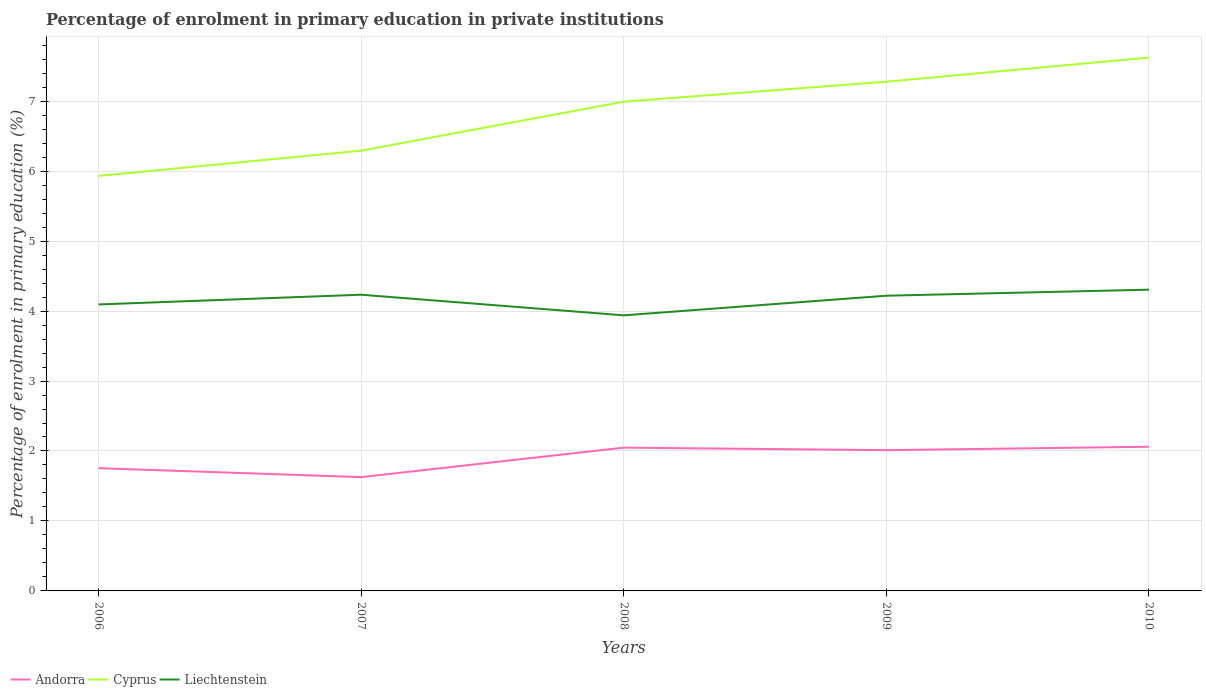Does the line corresponding to Liechtenstein intersect with the line corresponding to Cyprus?
Give a very brief answer. No. Is the number of lines equal to the number of legend labels?
Your answer should be very brief. Yes. Across all years, what is the maximum percentage of enrolment in primary education in Cyprus?
Provide a succinct answer. 5.93. What is the total percentage of enrolment in primary education in Andorra in the graph?
Provide a succinct answer. -0.42. What is the difference between the highest and the second highest percentage of enrolment in primary education in Andorra?
Keep it short and to the point. 0.43. What is the difference between the highest and the lowest percentage of enrolment in primary education in Andorra?
Provide a succinct answer. 3. How many years are there in the graph?
Offer a terse response. 5. Are the values on the major ticks of Y-axis written in scientific E-notation?
Keep it short and to the point. No. Does the graph contain any zero values?
Your answer should be very brief. No. Does the graph contain grids?
Your answer should be compact. Yes. Where does the legend appear in the graph?
Offer a terse response. Bottom left. How many legend labels are there?
Your answer should be compact. 3. What is the title of the graph?
Keep it short and to the point. Percentage of enrolment in primary education in private institutions. Does "Egypt, Arab Rep." appear as one of the legend labels in the graph?
Provide a short and direct response. No. What is the label or title of the Y-axis?
Your response must be concise. Percentage of enrolment in primary education (%). What is the Percentage of enrolment in primary education (%) in Andorra in 2006?
Provide a succinct answer. 1.75. What is the Percentage of enrolment in primary education (%) of Cyprus in 2006?
Offer a very short reply. 5.93. What is the Percentage of enrolment in primary education (%) in Liechtenstein in 2006?
Ensure brevity in your answer.  4.09. What is the Percentage of enrolment in primary education (%) of Andorra in 2007?
Offer a terse response. 1.63. What is the Percentage of enrolment in primary education (%) of Cyprus in 2007?
Your answer should be very brief. 6.29. What is the Percentage of enrolment in primary education (%) of Liechtenstein in 2007?
Offer a terse response. 4.23. What is the Percentage of enrolment in primary education (%) in Andorra in 2008?
Your answer should be very brief. 2.05. What is the Percentage of enrolment in primary education (%) of Cyprus in 2008?
Provide a short and direct response. 6.99. What is the Percentage of enrolment in primary education (%) of Liechtenstein in 2008?
Keep it short and to the point. 3.94. What is the Percentage of enrolment in primary education (%) in Andorra in 2009?
Make the answer very short. 2.01. What is the Percentage of enrolment in primary education (%) in Cyprus in 2009?
Provide a short and direct response. 7.28. What is the Percentage of enrolment in primary education (%) of Liechtenstein in 2009?
Your answer should be compact. 4.22. What is the Percentage of enrolment in primary education (%) of Andorra in 2010?
Keep it short and to the point. 2.06. What is the Percentage of enrolment in primary education (%) in Cyprus in 2010?
Your answer should be very brief. 7.62. What is the Percentage of enrolment in primary education (%) in Liechtenstein in 2010?
Provide a succinct answer. 4.31. Across all years, what is the maximum Percentage of enrolment in primary education (%) of Andorra?
Offer a very short reply. 2.06. Across all years, what is the maximum Percentage of enrolment in primary education (%) in Cyprus?
Your answer should be compact. 7.62. Across all years, what is the maximum Percentage of enrolment in primary education (%) in Liechtenstein?
Make the answer very short. 4.31. Across all years, what is the minimum Percentage of enrolment in primary education (%) in Andorra?
Provide a succinct answer. 1.63. Across all years, what is the minimum Percentage of enrolment in primary education (%) of Cyprus?
Your answer should be very brief. 5.93. Across all years, what is the minimum Percentage of enrolment in primary education (%) in Liechtenstein?
Ensure brevity in your answer.  3.94. What is the total Percentage of enrolment in primary education (%) of Andorra in the graph?
Offer a terse response. 9.5. What is the total Percentage of enrolment in primary education (%) of Cyprus in the graph?
Your answer should be very brief. 34.12. What is the total Percentage of enrolment in primary education (%) in Liechtenstein in the graph?
Provide a short and direct response. 20.79. What is the difference between the Percentage of enrolment in primary education (%) in Andorra in 2006 and that in 2007?
Make the answer very short. 0.13. What is the difference between the Percentage of enrolment in primary education (%) of Cyprus in 2006 and that in 2007?
Your response must be concise. -0.36. What is the difference between the Percentage of enrolment in primary education (%) in Liechtenstein in 2006 and that in 2007?
Provide a succinct answer. -0.14. What is the difference between the Percentage of enrolment in primary education (%) in Andorra in 2006 and that in 2008?
Keep it short and to the point. -0.29. What is the difference between the Percentage of enrolment in primary education (%) in Cyprus in 2006 and that in 2008?
Make the answer very short. -1.06. What is the difference between the Percentage of enrolment in primary education (%) of Liechtenstein in 2006 and that in 2008?
Offer a very short reply. 0.16. What is the difference between the Percentage of enrolment in primary education (%) in Andorra in 2006 and that in 2009?
Offer a terse response. -0.26. What is the difference between the Percentage of enrolment in primary education (%) in Cyprus in 2006 and that in 2009?
Make the answer very short. -1.35. What is the difference between the Percentage of enrolment in primary education (%) of Liechtenstein in 2006 and that in 2009?
Offer a terse response. -0.13. What is the difference between the Percentage of enrolment in primary education (%) of Andorra in 2006 and that in 2010?
Offer a very short reply. -0.31. What is the difference between the Percentage of enrolment in primary education (%) of Cyprus in 2006 and that in 2010?
Your response must be concise. -1.69. What is the difference between the Percentage of enrolment in primary education (%) of Liechtenstein in 2006 and that in 2010?
Your answer should be compact. -0.21. What is the difference between the Percentage of enrolment in primary education (%) in Andorra in 2007 and that in 2008?
Offer a very short reply. -0.42. What is the difference between the Percentage of enrolment in primary education (%) in Cyprus in 2007 and that in 2008?
Your response must be concise. -0.7. What is the difference between the Percentage of enrolment in primary education (%) of Liechtenstein in 2007 and that in 2008?
Offer a terse response. 0.29. What is the difference between the Percentage of enrolment in primary education (%) of Andorra in 2007 and that in 2009?
Your response must be concise. -0.39. What is the difference between the Percentage of enrolment in primary education (%) in Cyprus in 2007 and that in 2009?
Keep it short and to the point. -0.99. What is the difference between the Percentage of enrolment in primary education (%) in Liechtenstein in 2007 and that in 2009?
Your response must be concise. 0.01. What is the difference between the Percentage of enrolment in primary education (%) in Andorra in 2007 and that in 2010?
Provide a succinct answer. -0.43. What is the difference between the Percentage of enrolment in primary education (%) in Cyprus in 2007 and that in 2010?
Provide a succinct answer. -1.33. What is the difference between the Percentage of enrolment in primary education (%) in Liechtenstein in 2007 and that in 2010?
Make the answer very short. -0.07. What is the difference between the Percentage of enrolment in primary education (%) in Andorra in 2008 and that in 2009?
Give a very brief answer. 0.04. What is the difference between the Percentage of enrolment in primary education (%) of Cyprus in 2008 and that in 2009?
Offer a very short reply. -0.29. What is the difference between the Percentage of enrolment in primary education (%) in Liechtenstein in 2008 and that in 2009?
Your answer should be compact. -0.28. What is the difference between the Percentage of enrolment in primary education (%) in Andorra in 2008 and that in 2010?
Provide a short and direct response. -0.01. What is the difference between the Percentage of enrolment in primary education (%) in Cyprus in 2008 and that in 2010?
Offer a very short reply. -0.63. What is the difference between the Percentage of enrolment in primary education (%) in Liechtenstein in 2008 and that in 2010?
Offer a very short reply. -0.37. What is the difference between the Percentage of enrolment in primary education (%) in Andorra in 2009 and that in 2010?
Provide a short and direct response. -0.05. What is the difference between the Percentage of enrolment in primary education (%) of Cyprus in 2009 and that in 2010?
Your answer should be very brief. -0.34. What is the difference between the Percentage of enrolment in primary education (%) of Liechtenstein in 2009 and that in 2010?
Give a very brief answer. -0.09. What is the difference between the Percentage of enrolment in primary education (%) of Andorra in 2006 and the Percentage of enrolment in primary education (%) of Cyprus in 2007?
Give a very brief answer. -4.54. What is the difference between the Percentage of enrolment in primary education (%) in Andorra in 2006 and the Percentage of enrolment in primary education (%) in Liechtenstein in 2007?
Keep it short and to the point. -2.48. What is the difference between the Percentage of enrolment in primary education (%) of Cyprus in 2006 and the Percentage of enrolment in primary education (%) of Liechtenstein in 2007?
Your response must be concise. 1.7. What is the difference between the Percentage of enrolment in primary education (%) in Andorra in 2006 and the Percentage of enrolment in primary education (%) in Cyprus in 2008?
Give a very brief answer. -5.24. What is the difference between the Percentage of enrolment in primary education (%) in Andorra in 2006 and the Percentage of enrolment in primary education (%) in Liechtenstein in 2008?
Give a very brief answer. -2.18. What is the difference between the Percentage of enrolment in primary education (%) in Cyprus in 2006 and the Percentage of enrolment in primary education (%) in Liechtenstein in 2008?
Your response must be concise. 1.99. What is the difference between the Percentage of enrolment in primary education (%) of Andorra in 2006 and the Percentage of enrolment in primary education (%) of Cyprus in 2009?
Make the answer very short. -5.52. What is the difference between the Percentage of enrolment in primary education (%) in Andorra in 2006 and the Percentage of enrolment in primary education (%) in Liechtenstein in 2009?
Give a very brief answer. -2.46. What is the difference between the Percentage of enrolment in primary education (%) of Cyprus in 2006 and the Percentage of enrolment in primary education (%) of Liechtenstein in 2009?
Your response must be concise. 1.71. What is the difference between the Percentage of enrolment in primary education (%) of Andorra in 2006 and the Percentage of enrolment in primary education (%) of Cyprus in 2010?
Ensure brevity in your answer.  -5.87. What is the difference between the Percentage of enrolment in primary education (%) of Andorra in 2006 and the Percentage of enrolment in primary education (%) of Liechtenstein in 2010?
Ensure brevity in your answer.  -2.55. What is the difference between the Percentage of enrolment in primary education (%) of Cyprus in 2006 and the Percentage of enrolment in primary education (%) of Liechtenstein in 2010?
Provide a short and direct response. 1.63. What is the difference between the Percentage of enrolment in primary education (%) of Andorra in 2007 and the Percentage of enrolment in primary education (%) of Cyprus in 2008?
Keep it short and to the point. -5.37. What is the difference between the Percentage of enrolment in primary education (%) of Andorra in 2007 and the Percentage of enrolment in primary education (%) of Liechtenstein in 2008?
Keep it short and to the point. -2.31. What is the difference between the Percentage of enrolment in primary education (%) in Cyprus in 2007 and the Percentage of enrolment in primary education (%) in Liechtenstein in 2008?
Provide a short and direct response. 2.35. What is the difference between the Percentage of enrolment in primary education (%) of Andorra in 2007 and the Percentage of enrolment in primary education (%) of Cyprus in 2009?
Offer a very short reply. -5.65. What is the difference between the Percentage of enrolment in primary education (%) of Andorra in 2007 and the Percentage of enrolment in primary education (%) of Liechtenstein in 2009?
Your answer should be compact. -2.59. What is the difference between the Percentage of enrolment in primary education (%) of Cyprus in 2007 and the Percentage of enrolment in primary education (%) of Liechtenstein in 2009?
Offer a terse response. 2.07. What is the difference between the Percentage of enrolment in primary education (%) in Andorra in 2007 and the Percentage of enrolment in primary education (%) in Cyprus in 2010?
Your answer should be very brief. -6. What is the difference between the Percentage of enrolment in primary education (%) in Andorra in 2007 and the Percentage of enrolment in primary education (%) in Liechtenstein in 2010?
Provide a succinct answer. -2.68. What is the difference between the Percentage of enrolment in primary education (%) of Cyprus in 2007 and the Percentage of enrolment in primary education (%) of Liechtenstein in 2010?
Your answer should be compact. 1.99. What is the difference between the Percentage of enrolment in primary education (%) of Andorra in 2008 and the Percentage of enrolment in primary education (%) of Cyprus in 2009?
Make the answer very short. -5.23. What is the difference between the Percentage of enrolment in primary education (%) of Andorra in 2008 and the Percentage of enrolment in primary education (%) of Liechtenstein in 2009?
Keep it short and to the point. -2.17. What is the difference between the Percentage of enrolment in primary education (%) of Cyprus in 2008 and the Percentage of enrolment in primary education (%) of Liechtenstein in 2009?
Provide a succinct answer. 2.77. What is the difference between the Percentage of enrolment in primary education (%) of Andorra in 2008 and the Percentage of enrolment in primary education (%) of Cyprus in 2010?
Give a very brief answer. -5.58. What is the difference between the Percentage of enrolment in primary education (%) in Andorra in 2008 and the Percentage of enrolment in primary education (%) in Liechtenstein in 2010?
Your response must be concise. -2.26. What is the difference between the Percentage of enrolment in primary education (%) of Cyprus in 2008 and the Percentage of enrolment in primary education (%) of Liechtenstein in 2010?
Provide a short and direct response. 2.69. What is the difference between the Percentage of enrolment in primary education (%) of Andorra in 2009 and the Percentage of enrolment in primary education (%) of Cyprus in 2010?
Give a very brief answer. -5.61. What is the difference between the Percentage of enrolment in primary education (%) of Andorra in 2009 and the Percentage of enrolment in primary education (%) of Liechtenstein in 2010?
Provide a short and direct response. -2.29. What is the difference between the Percentage of enrolment in primary education (%) in Cyprus in 2009 and the Percentage of enrolment in primary education (%) in Liechtenstein in 2010?
Offer a very short reply. 2.97. What is the average Percentage of enrolment in primary education (%) of Andorra per year?
Offer a terse response. 1.9. What is the average Percentage of enrolment in primary education (%) in Cyprus per year?
Give a very brief answer. 6.82. What is the average Percentage of enrolment in primary education (%) of Liechtenstein per year?
Keep it short and to the point. 4.16. In the year 2006, what is the difference between the Percentage of enrolment in primary education (%) of Andorra and Percentage of enrolment in primary education (%) of Cyprus?
Make the answer very short. -4.18. In the year 2006, what is the difference between the Percentage of enrolment in primary education (%) in Andorra and Percentage of enrolment in primary education (%) in Liechtenstein?
Give a very brief answer. -2.34. In the year 2006, what is the difference between the Percentage of enrolment in primary education (%) of Cyprus and Percentage of enrolment in primary education (%) of Liechtenstein?
Your answer should be very brief. 1.84. In the year 2007, what is the difference between the Percentage of enrolment in primary education (%) of Andorra and Percentage of enrolment in primary education (%) of Cyprus?
Offer a terse response. -4.67. In the year 2007, what is the difference between the Percentage of enrolment in primary education (%) in Andorra and Percentage of enrolment in primary education (%) in Liechtenstein?
Provide a succinct answer. -2.61. In the year 2007, what is the difference between the Percentage of enrolment in primary education (%) of Cyprus and Percentage of enrolment in primary education (%) of Liechtenstein?
Your answer should be compact. 2.06. In the year 2008, what is the difference between the Percentage of enrolment in primary education (%) of Andorra and Percentage of enrolment in primary education (%) of Cyprus?
Your answer should be very brief. -4.95. In the year 2008, what is the difference between the Percentage of enrolment in primary education (%) in Andorra and Percentage of enrolment in primary education (%) in Liechtenstein?
Keep it short and to the point. -1.89. In the year 2008, what is the difference between the Percentage of enrolment in primary education (%) of Cyprus and Percentage of enrolment in primary education (%) of Liechtenstein?
Ensure brevity in your answer.  3.05. In the year 2009, what is the difference between the Percentage of enrolment in primary education (%) in Andorra and Percentage of enrolment in primary education (%) in Cyprus?
Offer a very short reply. -5.27. In the year 2009, what is the difference between the Percentage of enrolment in primary education (%) of Andorra and Percentage of enrolment in primary education (%) of Liechtenstein?
Ensure brevity in your answer.  -2.21. In the year 2009, what is the difference between the Percentage of enrolment in primary education (%) in Cyprus and Percentage of enrolment in primary education (%) in Liechtenstein?
Provide a short and direct response. 3.06. In the year 2010, what is the difference between the Percentage of enrolment in primary education (%) in Andorra and Percentage of enrolment in primary education (%) in Cyprus?
Your answer should be very brief. -5.56. In the year 2010, what is the difference between the Percentage of enrolment in primary education (%) in Andorra and Percentage of enrolment in primary education (%) in Liechtenstein?
Provide a short and direct response. -2.24. In the year 2010, what is the difference between the Percentage of enrolment in primary education (%) in Cyprus and Percentage of enrolment in primary education (%) in Liechtenstein?
Give a very brief answer. 3.32. What is the ratio of the Percentage of enrolment in primary education (%) of Andorra in 2006 to that in 2007?
Your answer should be very brief. 1.08. What is the ratio of the Percentage of enrolment in primary education (%) in Cyprus in 2006 to that in 2007?
Keep it short and to the point. 0.94. What is the ratio of the Percentage of enrolment in primary education (%) in Liechtenstein in 2006 to that in 2007?
Give a very brief answer. 0.97. What is the ratio of the Percentage of enrolment in primary education (%) of Andorra in 2006 to that in 2008?
Provide a short and direct response. 0.86. What is the ratio of the Percentage of enrolment in primary education (%) of Cyprus in 2006 to that in 2008?
Make the answer very short. 0.85. What is the ratio of the Percentage of enrolment in primary education (%) of Liechtenstein in 2006 to that in 2008?
Provide a succinct answer. 1.04. What is the ratio of the Percentage of enrolment in primary education (%) in Andorra in 2006 to that in 2009?
Your response must be concise. 0.87. What is the ratio of the Percentage of enrolment in primary education (%) in Cyprus in 2006 to that in 2009?
Your answer should be very brief. 0.81. What is the ratio of the Percentage of enrolment in primary education (%) of Liechtenstein in 2006 to that in 2009?
Your response must be concise. 0.97. What is the ratio of the Percentage of enrolment in primary education (%) of Andorra in 2006 to that in 2010?
Provide a short and direct response. 0.85. What is the ratio of the Percentage of enrolment in primary education (%) of Cyprus in 2006 to that in 2010?
Offer a terse response. 0.78. What is the ratio of the Percentage of enrolment in primary education (%) in Liechtenstein in 2006 to that in 2010?
Make the answer very short. 0.95. What is the ratio of the Percentage of enrolment in primary education (%) of Andorra in 2007 to that in 2008?
Your response must be concise. 0.79. What is the ratio of the Percentage of enrolment in primary education (%) in Cyprus in 2007 to that in 2008?
Your answer should be compact. 0.9. What is the ratio of the Percentage of enrolment in primary education (%) of Liechtenstein in 2007 to that in 2008?
Your answer should be compact. 1.07. What is the ratio of the Percentage of enrolment in primary education (%) of Andorra in 2007 to that in 2009?
Your answer should be very brief. 0.81. What is the ratio of the Percentage of enrolment in primary education (%) of Cyprus in 2007 to that in 2009?
Your response must be concise. 0.86. What is the ratio of the Percentage of enrolment in primary education (%) of Andorra in 2007 to that in 2010?
Your answer should be compact. 0.79. What is the ratio of the Percentage of enrolment in primary education (%) of Cyprus in 2007 to that in 2010?
Your response must be concise. 0.83. What is the ratio of the Percentage of enrolment in primary education (%) of Liechtenstein in 2007 to that in 2010?
Offer a terse response. 0.98. What is the ratio of the Percentage of enrolment in primary education (%) of Andorra in 2008 to that in 2009?
Give a very brief answer. 1.02. What is the ratio of the Percentage of enrolment in primary education (%) in Cyprus in 2008 to that in 2009?
Offer a terse response. 0.96. What is the ratio of the Percentage of enrolment in primary education (%) of Liechtenstein in 2008 to that in 2009?
Ensure brevity in your answer.  0.93. What is the ratio of the Percentage of enrolment in primary education (%) of Cyprus in 2008 to that in 2010?
Provide a succinct answer. 0.92. What is the ratio of the Percentage of enrolment in primary education (%) of Liechtenstein in 2008 to that in 2010?
Offer a very short reply. 0.91. What is the ratio of the Percentage of enrolment in primary education (%) of Andorra in 2009 to that in 2010?
Offer a terse response. 0.98. What is the ratio of the Percentage of enrolment in primary education (%) of Cyprus in 2009 to that in 2010?
Give a very brief answer. 0.95. What is the ratio of the Percentage of enrolment in primary education (%) in Liechtenstein in 2009 to that in 2010?
Ensure brevity in your answer.  0.98. What is the difference between the highest and the second highest Percentage of enrolment in primary education (%) of Andorra?
Offer a terse response. 0.01. What is the difference between the highest and the second highest Percentage of enrolment in primary education (%) of Cyprus?
Provide a short and direct response. 0.34. What is the difference between the highest and the second highest Percentage of enrolment in primary education (%) in Liechtenstein?
Make the answer very short. 0.07. What is the difference between the highest and the lowest Percentage of enrolment in primary education (%) in Andorra?
Your answer should be compact. 0.43. What is the difference between the highest and the lowest Percentage of enrolment in primary education (%) of Cyprus?
Offer a very short reply. 1.69. What is the difference between the highest and the lowest Percentage of enrolment in primary education (%) in Liechtenstein?
Offer a terse response. 0.37. 